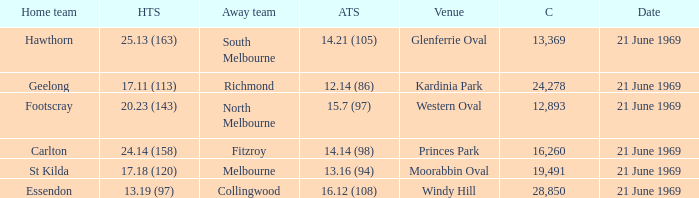When did an away team score 15.7 (97)? 21 June 1969. 